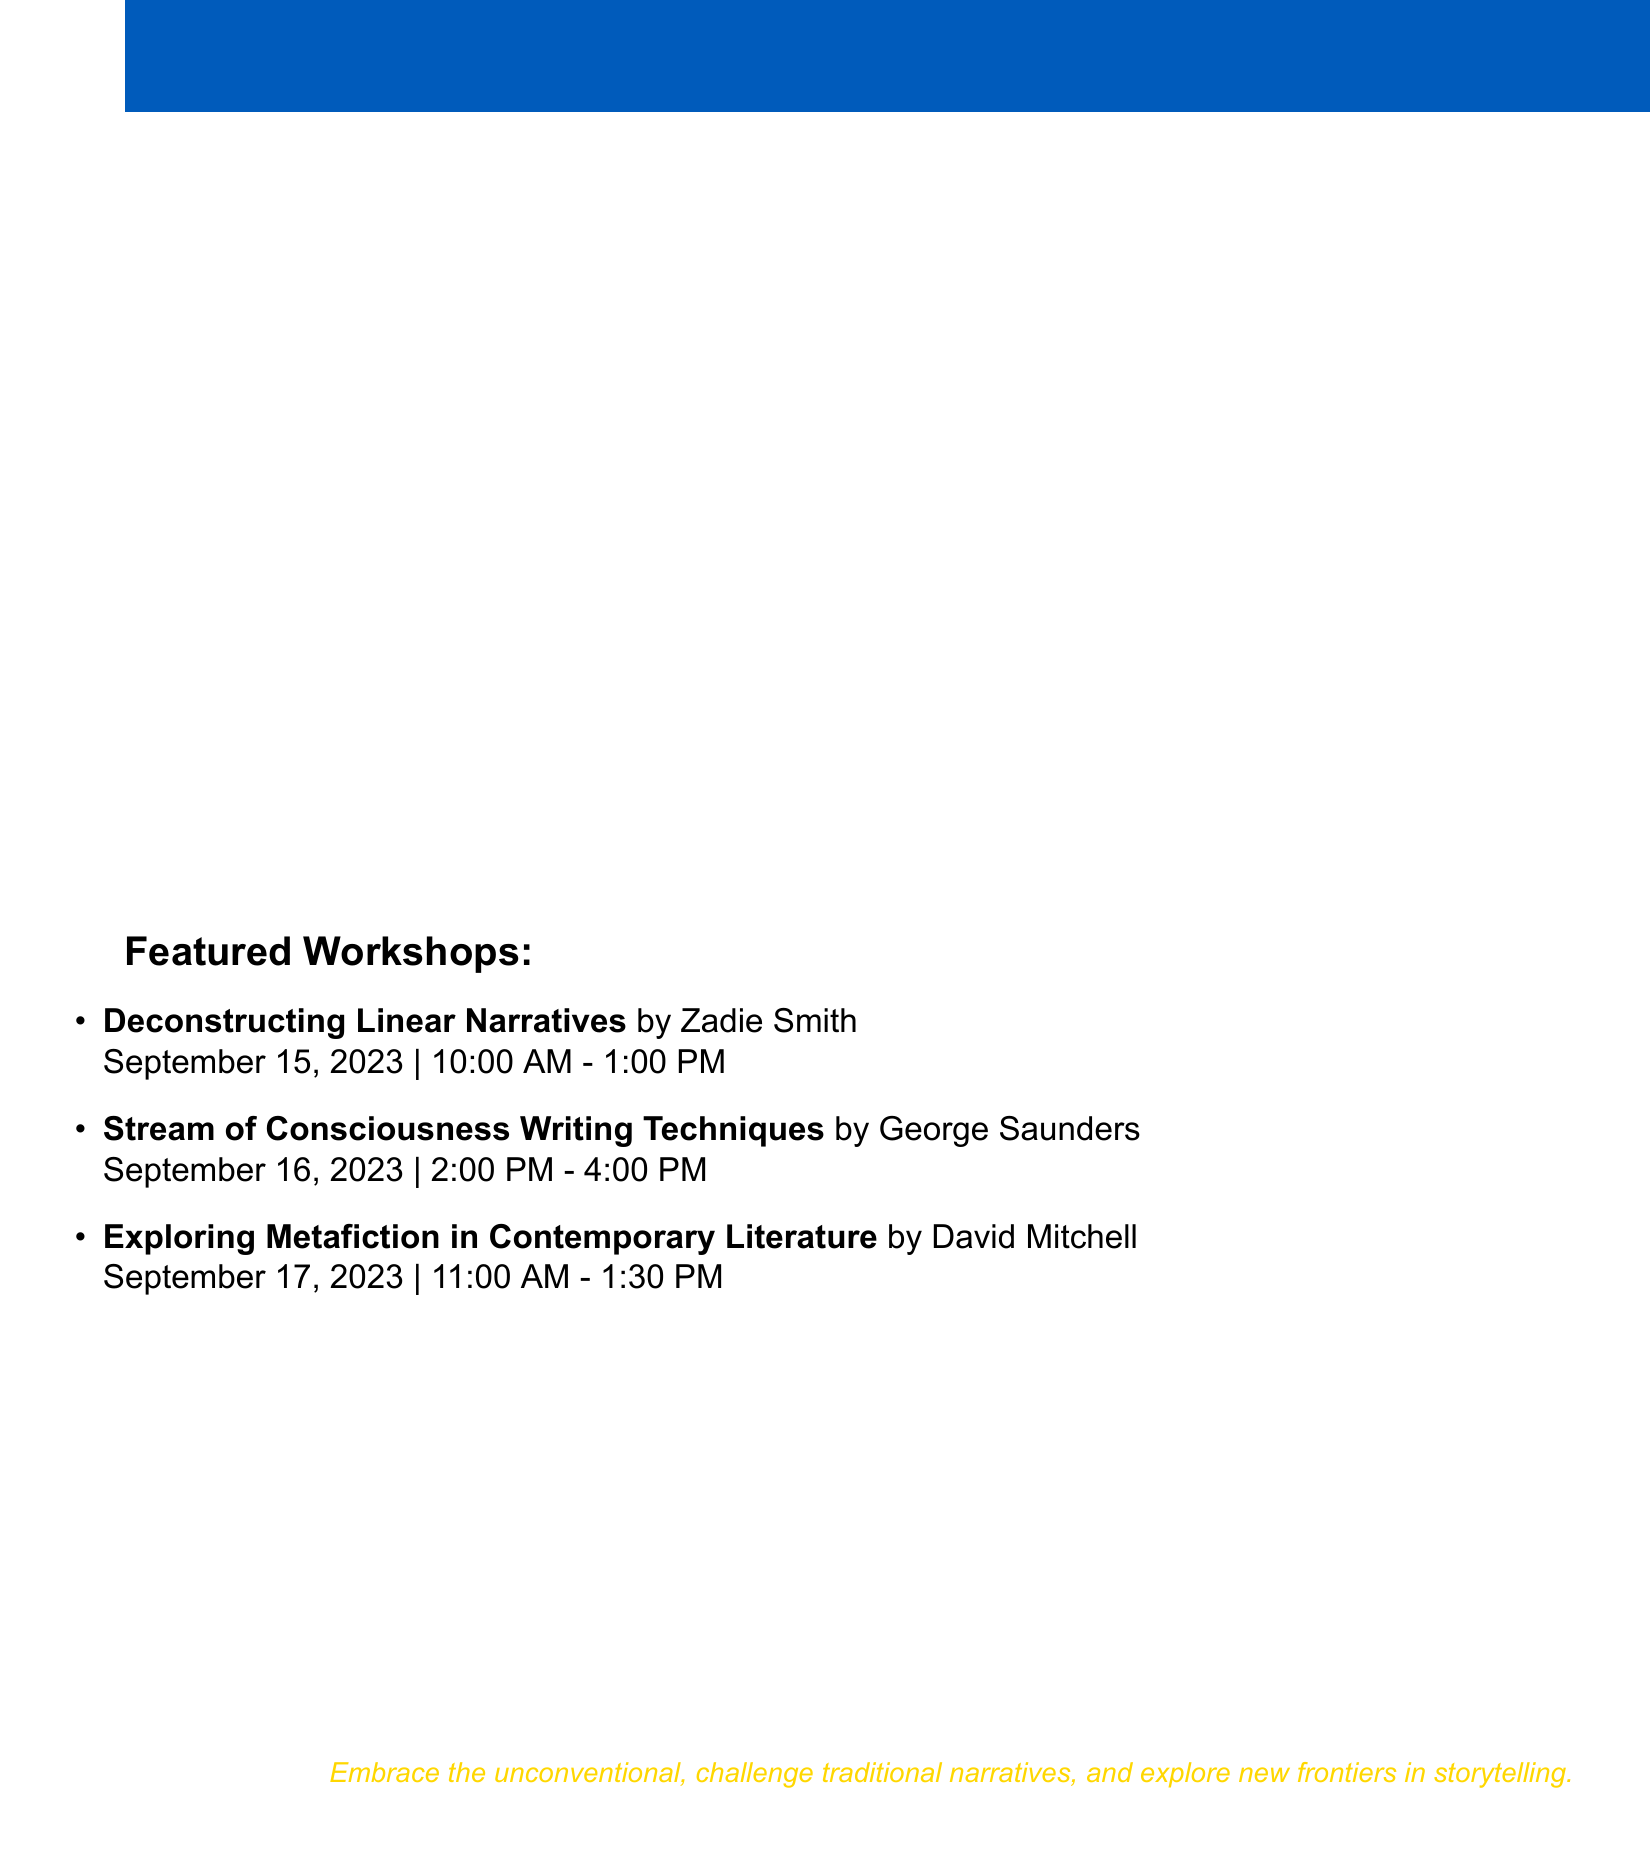What is the name of the festival? The festival is called the Avant-Garde Literary Symposium.
Answer: Avant-Garde Literary Symposium Where is the festival located? The document states that the location is New School for Social Research, New York City.
Answer: New School for Social Research, New York City Who is the purchaser? The purchaser's name is Alex Kovalev, as mentioned in the details.
Answer: Alex Kovalev How much does a Full Access Pass cost? The document lists the price of the Full Access Pass as $299.99 USD.
Answer: $299.99 When is the workshop "Exploring Metafiction in Contemporary Literature"? The workshop is scheduled for September 17, 2023.
Answer: September 17, 2023 What is one of the included benefits of the ticket? The ticket includes access to all workshops and panel discussions, among other benefits.
Answer: Access to all workshops and panel discussions How long is the "Deconstructing Linear Narratives" workshop? The document states that this workshop has a duration of 3 hours.
Answer: 3 hours What type of event is the "Experimental Fiction Open Mic"? It is categorized as a special event in the document.
Answer: Special event What payment method was used for the transaction? The payment method specified in the receipt is Credit Card.
Answer: Credit Card 